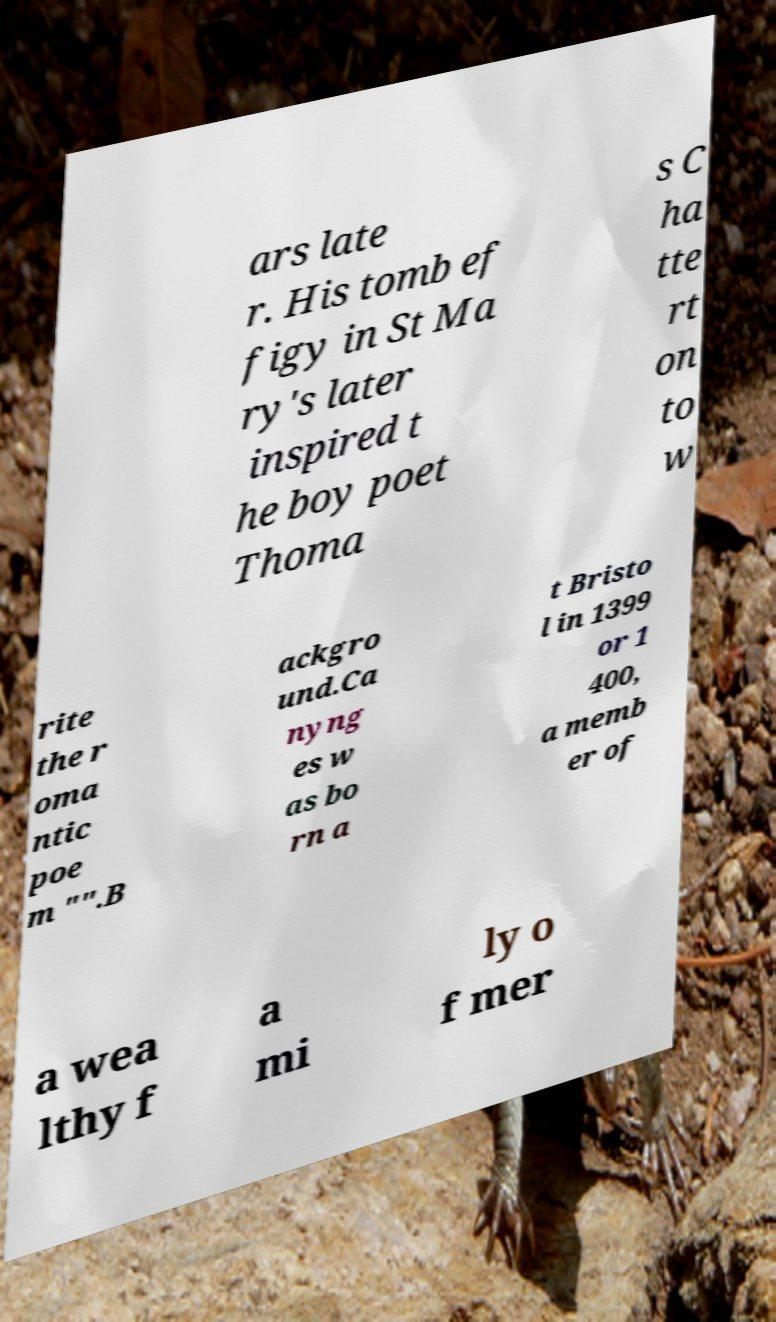There's text embedded in this image that I need extracted. Can you transcribe it verbatim? ars late r. His tomb ef figy in St Ma ry's later inspired t he boy poet Thoma s C ha tte rt on to w rite the r oma ntic poe m "".B ackgro und.Ca nyng es w as bo rn a t Bristo l in 1399 or 1 400, a memb er of a wea lthy f a mi ly o f mer 